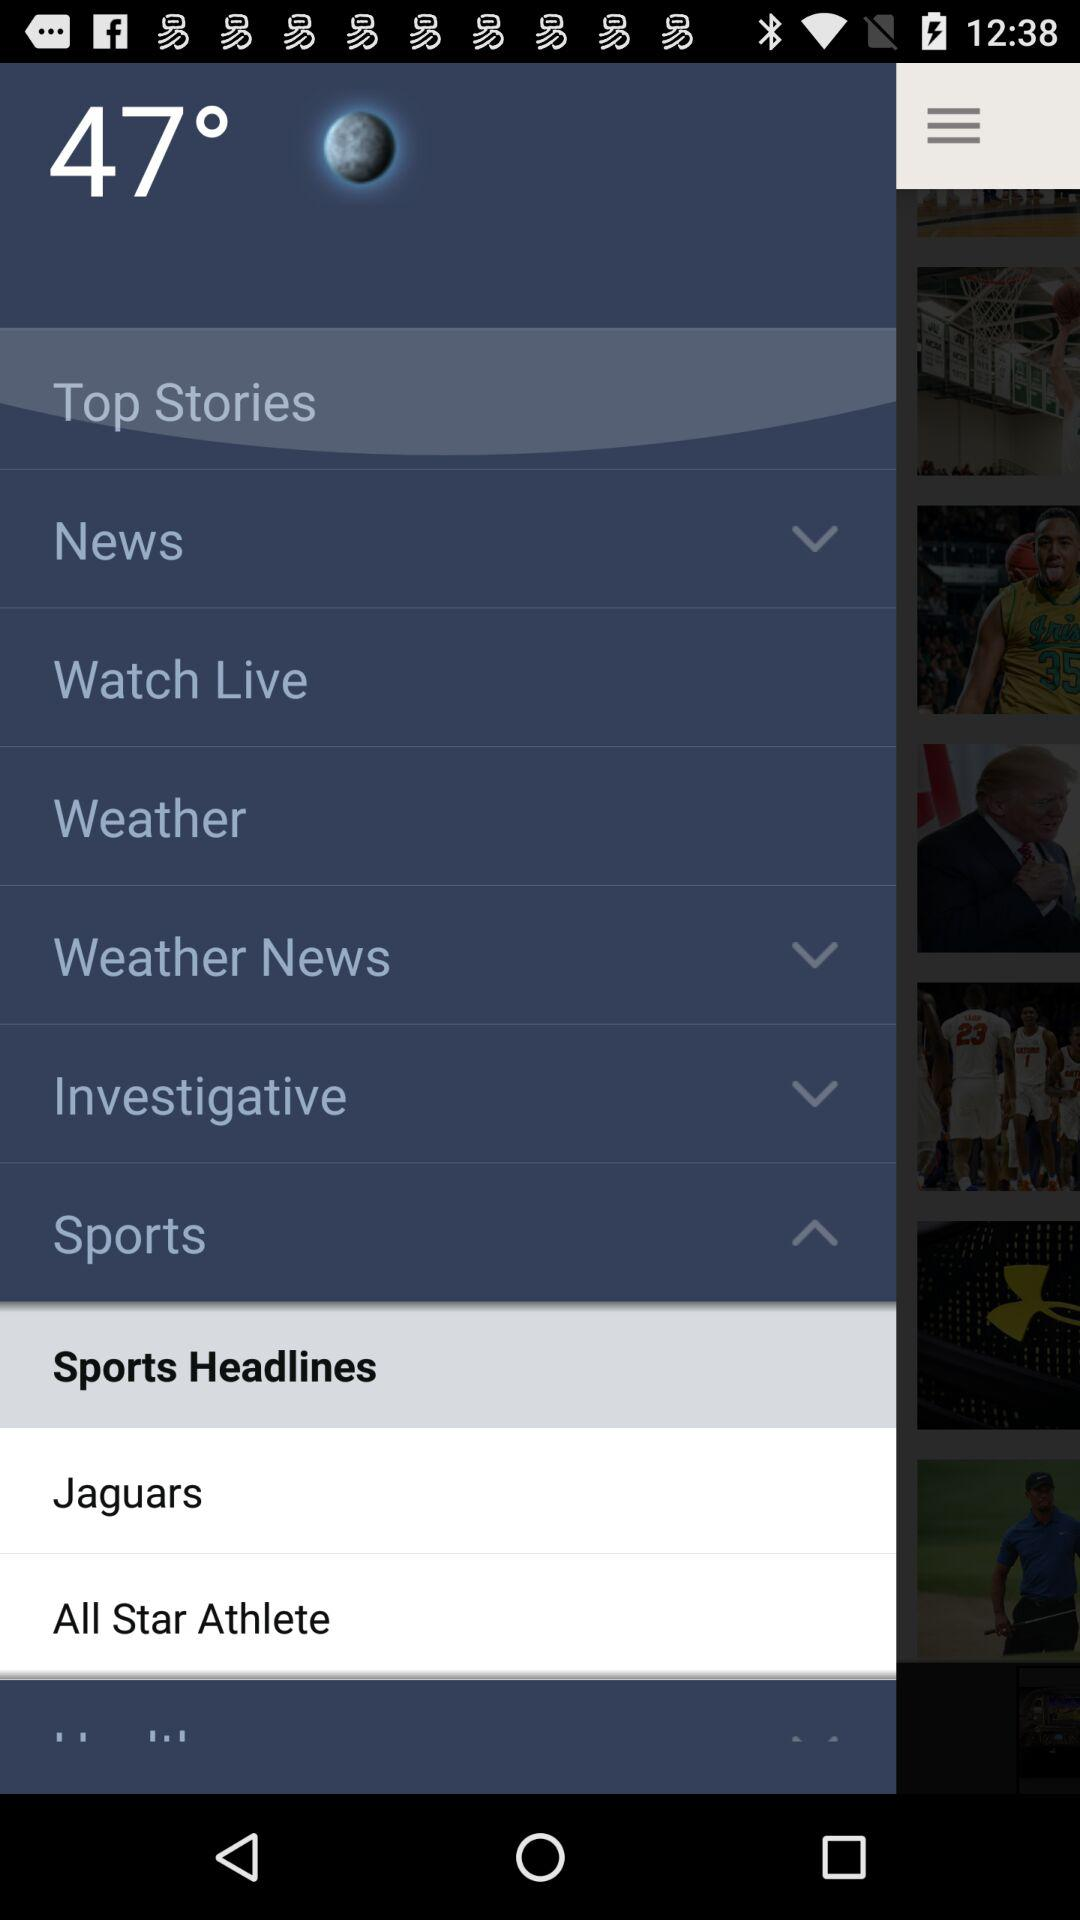What is the temperature? The temperature is 47°. 